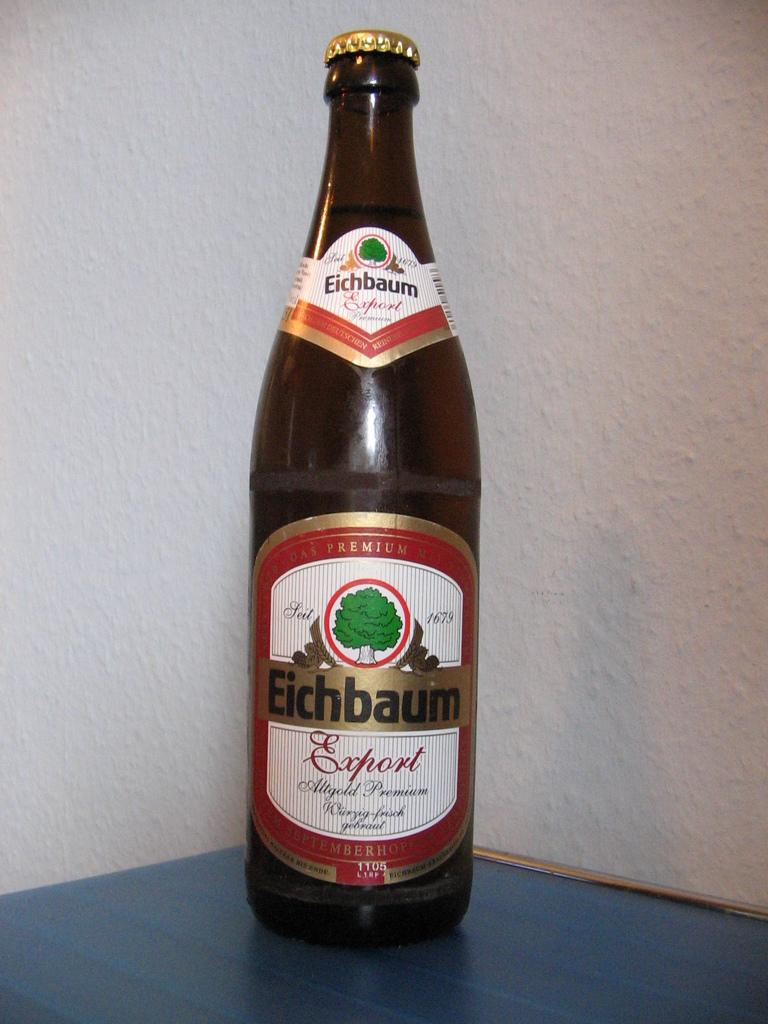<image>
Provide a brief description of the given image. A bottle is labeled Eichbaum and has a tree on it. 